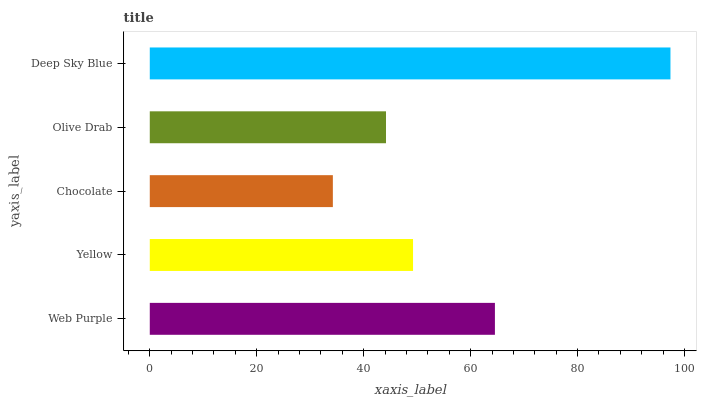Is Chocolate the minimum?
Answer yes or no. Yes. Is Deep Sky Blue the maximum?
Answer yes or no. Yes. Is Yellow the minimum?
Answer yes or no. No. Is Yellow the maximum?
Answer yes or no. No. Is Web Purple greater than Yellow?
Answer yes or no. Yes. Is Yellow less than Web Purple?
Answer yes or no. Yes. Is Yellow greater than Web Purple?
Answer yes or no. No. Is Web Purple less than Yellow?
Answer yes or no. No. Is Yellow the high median?
Answer yes or no. Yes. Is Yellow the low median?
Answer yes or no. Yes. Is Deep Sky Blue the high median?
Answer yes or no. No. Is Web Purple the low median?
Answer yes or no. No. 